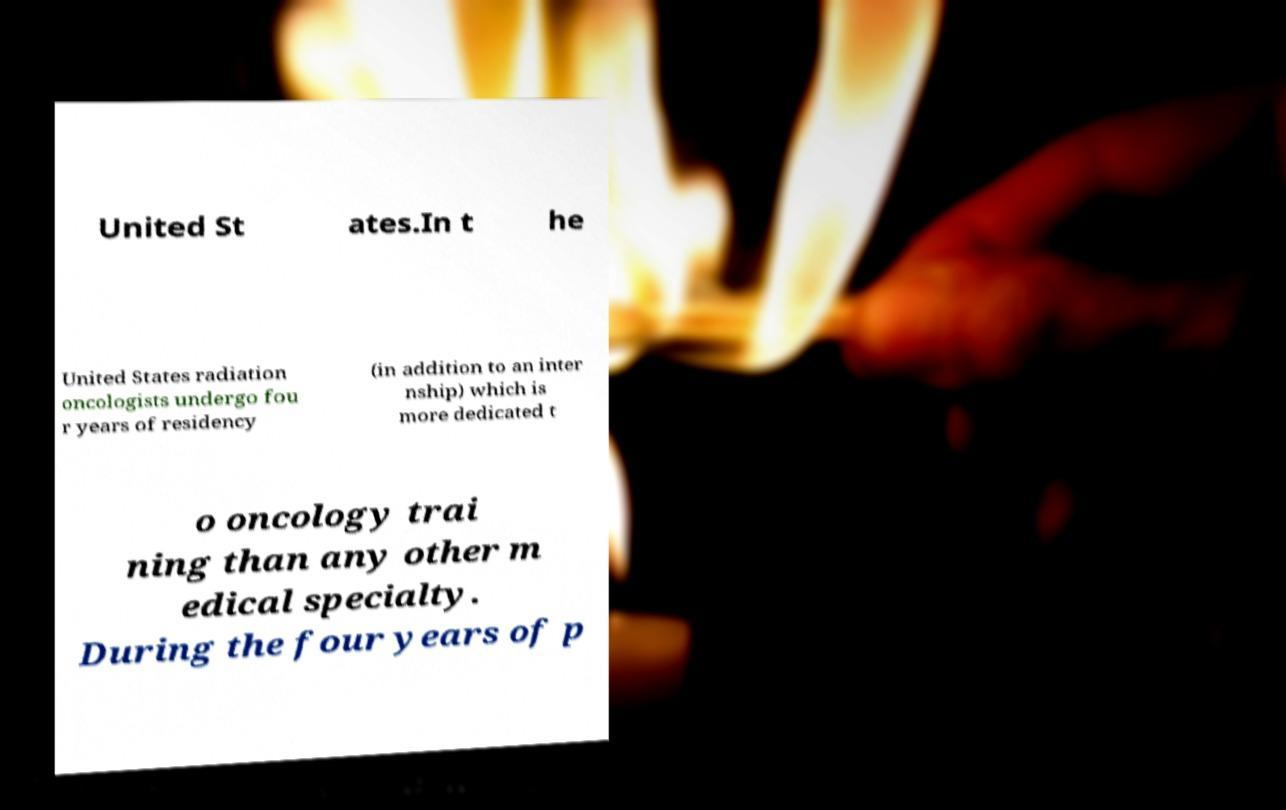There's text embedded in this image that I need extracted. Can you transcribe it verbatim? United St ates.In t he United States radiation oncologists undergo fou r years of residency (in addition to an inter nship) which is more dedicated t o oncology trai ning than any other m edical specialty. During the four years of p 